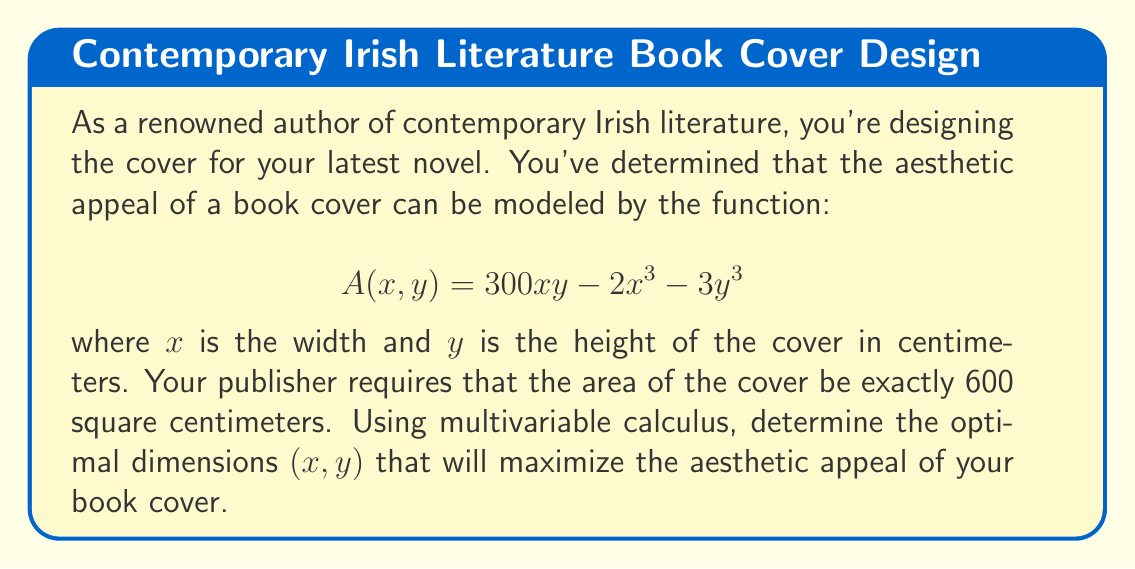Help me with this question. To solve this problem, we'll use the method of Lagrange multipliers, as we need to maximize a function subject to a constraint.

1) First, let's define our constraint function. The area of the cover must be 600 cm²:
   $$g(x,y) = xy - 600 = 0$$

2) Now, we form the Lagrangian function:
   $$L(x,y,\lambda) = A(x,y) - \lambda g(x,y)$$
   $$L(x,y,\lambda) = 300xy - 2x^3 - 3y^3 - \lambda(xy - 600)$$

3) We find the partial derivatives and set them to zero:
   $$\frac{\partial L}{\partial x} = 300y - 6x^2 - \lambda y = 0$$
   $$\frac{\partial L}{\partial y} = 300x - 9y^2 - \lambda x = 0$$
   $$\frac{\partial L}{\partial \lambda} = xy - 600 = 0$$

4) From the first two equations:
   $$300y - 6x^2 = \lambda y$$
   $$300x - 9y^2 = \lambda x$$

5) Dividing these equations:
   $$\frac{300y - 6x^2}{300x - 9y^2} = \frac{y}{x}$$

6) Cross-multiplying and simplifying:
   $$(300y - 6x^2)x = (300x - 9y^2)y$$
   $$300xy - 6x^3 = 300xy - 9y^3$$
   $$9y^3 = 6x^3$$
   $$y^3 = \frac{2}{3}x^3$$
   $$y = \sqrt[3]{\frac{2}{3}}x$$

7) Substituting this into our constraint equation:
   $$x(\sqrt[3]{\frac{2}{3}}x) = 600$$
   $$\sqrt[3]{\frac{2}{3}}x^2 = 600$$
   $$x^2 = 600 \cdot \sqrt[3]{\frac{3}{2}}$$
   $$x = \sqrt{600 \cdot \sqrt[3]{\frac{3}{2}}} \approx 30$$

8) And solving for y:
   $$y = \sqrt[3]{\frac{2}{3}}x \approx 25$$

Therefore, the optimal dimensions are approximately 30 cm wide and 25 cm tall.
Answer: The optimal dimensions for the book cover are approximately 30 cm wide and 25 cm tall. 